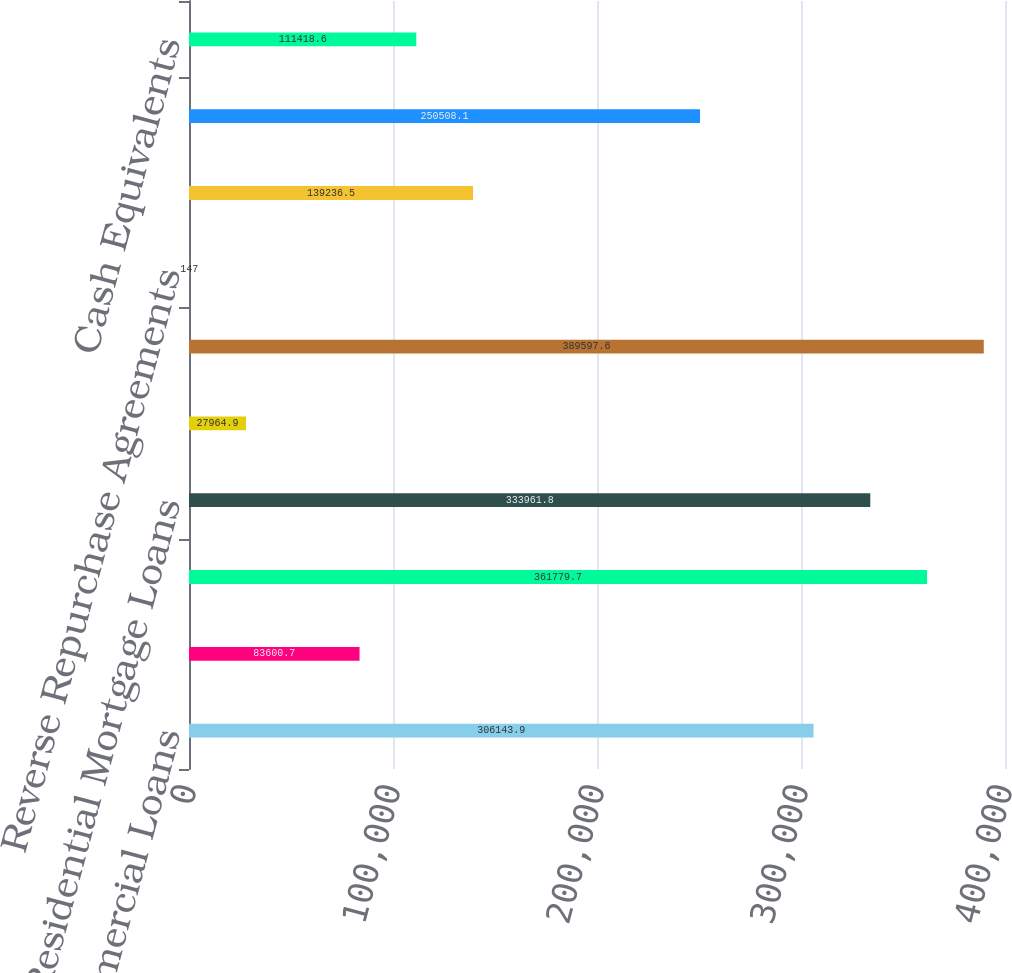Convert chart to OTSL. <chart><loc_0><loc_0><loc_500><loc_500><bar_chart><fcel>Commercial Loans<fcel>Real Estate Construction Loans<fcel>Commercial Real Estate Loans<fcel>Residential Mortgage Loans<fcel>Consumer Loans<fcel>Total Loans Net<fcel>Reverse Repurchase Agreements<fcel>Agency Mortgage Backed S<fcel>ii Non-agency Collateralized<fcel>Cash Equivalents<nl><fcel>306144<fcel>83600.7<fcel>361780<fcel>333962<fcel>27964.9<fcel>389598<fcel>147<fcel>139236<fcel>250508<fcel>111419<nl></chart> 